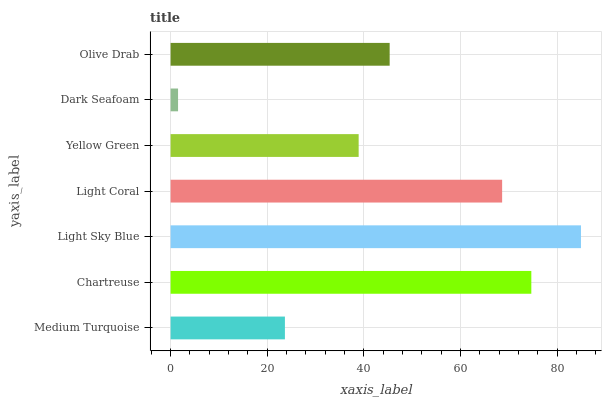Is Dark Seafoam the minimum?
Answer yes or no. Yes. Is Light Sky Blue the maximum?
Answer yes or no. Yes. Is Chartreuse the minimum?
Answer yes or no. No. Is Chartreuse the maximum?
Answer yes or no. No. Is Chartreuse greater than Medium Turquoise?
Answer yes or no. Yes. Is Medium Turquoise less than Chartreuse?
Answer yes or no. Yes. Is Medium Turquoise greater than Chartreuse?
Answer yes or no. No. Is Chartreuse less than Medium Turquoise?
Answer yes or no. No. Is Olive Drab the high median?
Answer yes or no. Yes. Is Olive Drab the low median?
Answer yes or no. Yes. Is Chartreuse the high median?
Answer yes or no. No. Is Medium Turquoise the low median?
Answer yes or no. No. 